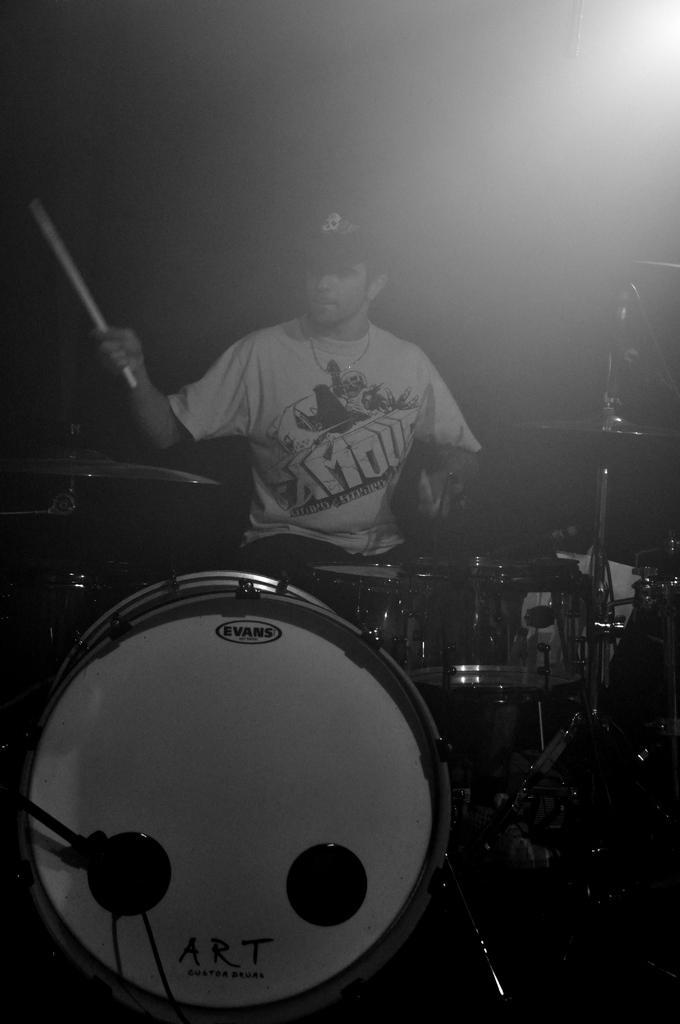How would you summarize this image in a sentence or two? In this image we can see a person is sitting and playing drums. 